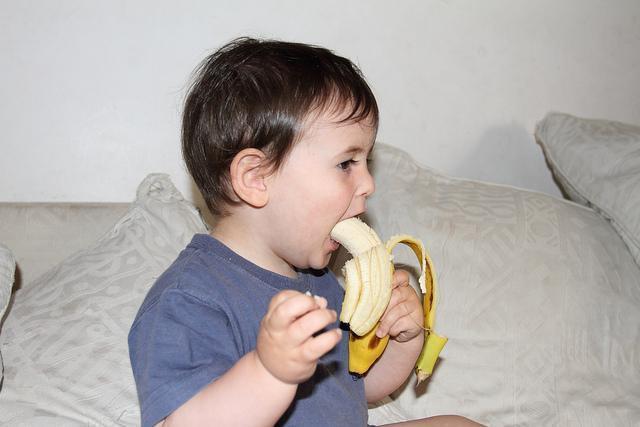How many beds are visible?
Give a very brief answer. 1. 